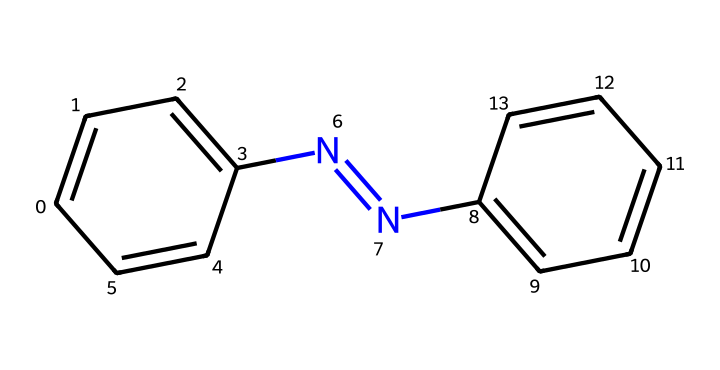What is the molecular formula of azobenzene? To determine the molecular formula, we analyze the chemical structure represented by the SMILES. The structure contains 12 carbon atoms (C), 10 hydrogen atoms (H), and 2 nitrogen atoms (N). Thus, the molecular formula is C12H10N2.
Answer: C12H10N2 How many double bonds are present in azobenzene? In azobenzene, there are two nitrogen double bonds (N=N) and four carbon double bonds (C=C in the aromatic rings). Summing these gives a total of 6 double bonds.
Answer: 6 What type of chemical structure does azobenzene represent? Azobenzene represents a photoreactive or photoswitchable structure due to the presence of the azo group (N=N), which can change configuration upon light exposure.
Answer: photoreactive How many rings are in the azobenzene structure? Azobenzene contains two benzene rings in its structure. We identify them as two sets of six carbon atoms each, arranged in a cyclic formation.
Answer: 2 Which functional group is responsible for the photoswitchable properties of azobenzene? The azo group (N=N) is responsible for the photoswitchable properties, as it undergoes isomerization when exposed to light, changing from trans to cis forms.
Answer: azo group What happens to azobenzene when exposed to ultraviolet light? Upon exposure to ultraviolet light, azobenzene undergoes isomerization from its trans configuration to the cis configuration, illustrating its photoswitchable properties.
Answer: isomerization What is the main application of azobenzene in marketing materials? Azobenzene is primarily used in smart inks that can change color or transparency in response to light changes, making it valuable for marketing materials that require interactive features.
Answer: smart inks 